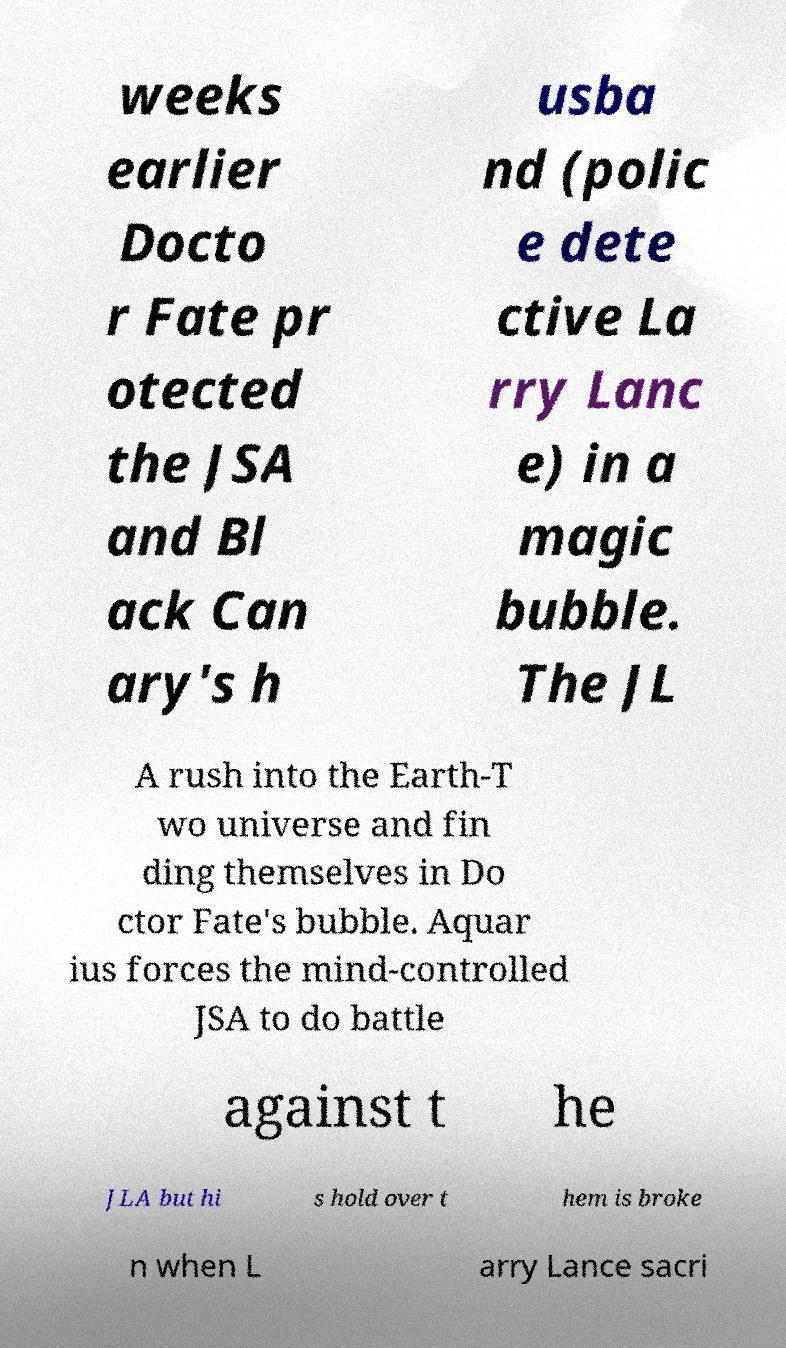For documentation purposes, I need the text within this image transcribed. Could you provide that? weeks earlier Docto r Fate pr otected the JSA and Bl ack Can ary's h usba nd (polic e dete ctive La rry Lanc e) in a magic bubble. The JL A rush into the Earth-T wo universe and fin ding themselves in Do ctor Fate's bubble. Aquar ius forces the mind-controlled JSA to do battle against t he JLA but hi s hold over t hem is broke n when L arry Lance sacri 